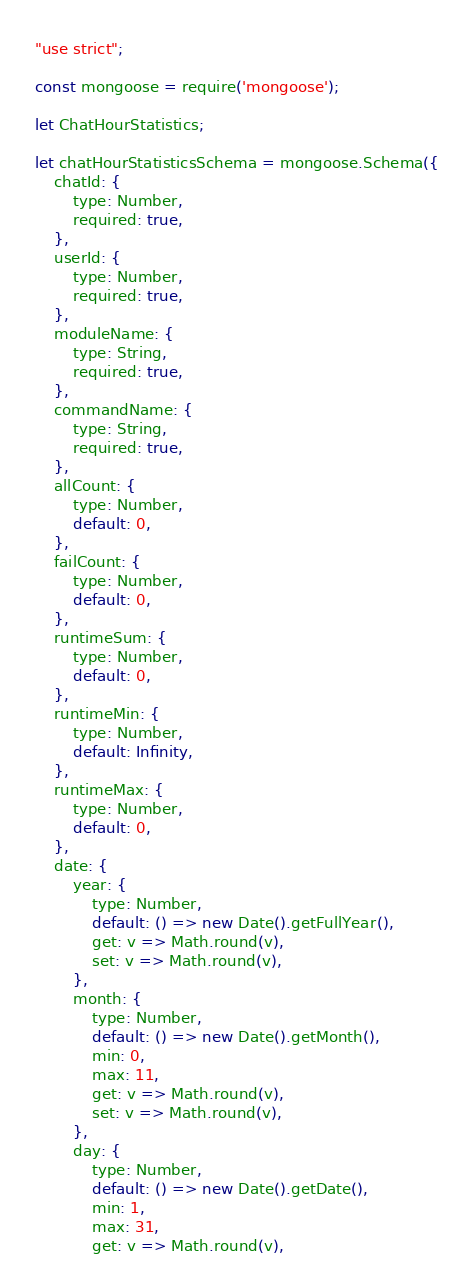<code> <loc_0><loc_0><loc_500><loc_500><_JavaScript_>"use strict";

const mongoose = require('mongoose');

let ChatHourStatistics;

let chatHourStatisticsSchema = mongoose.Schema({
    chatId: {
        type: Number,
        required: true,
    },
    userId: {
        type: Number,
        required: true,
    },
    moduleName: {
        type: String,
        required: true,
    },
    commandName: {
        type: String,
        required: true,
    },
    allCount: {
        type: Number,
        default: 0,
    },
    failCount: {
        type: Number,
        default: 0,
    },
    runtimeSum: {
        type: Number,
        default: 0,
    },
    runtimeMin: {
        type: Number,
        default: Infinity,
    },
    runtimeMax: {
        type: Number,
        default: 0,
    },
    date: {
        year: {
            type: Number,
            default: () => new Date().getFullYear(),
            get: v => Math.round(v),
            set: v => Math.round(v),
        },
        month: {
            type: Number,
            default: () => new Date().getMonth(),
            min: 0,
            max: 11,
            get: v => Math.round(v),
            set: v => Math.round(v),
        },
        day: {
            type: Number,
            default: () => new Date().getDate(),
            min: 1,
            max: 31,
            get: v => Math.round(v),</code> 